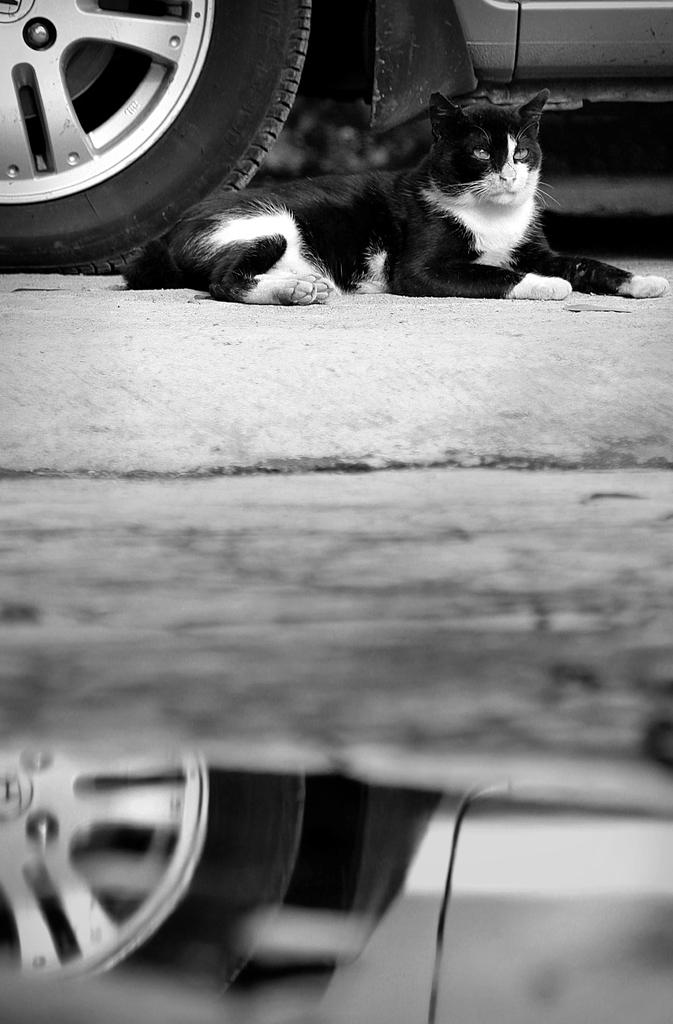What type of animal is in the image? There is a cat in the image. What is the cat doing in the image? The cat is laying on the ground. What other object can be seen in the image? There is a wheel in the image. What type of suit is the cat wearing in the image? There is no suit present in the image, as the cat is not wearing any clothing. 